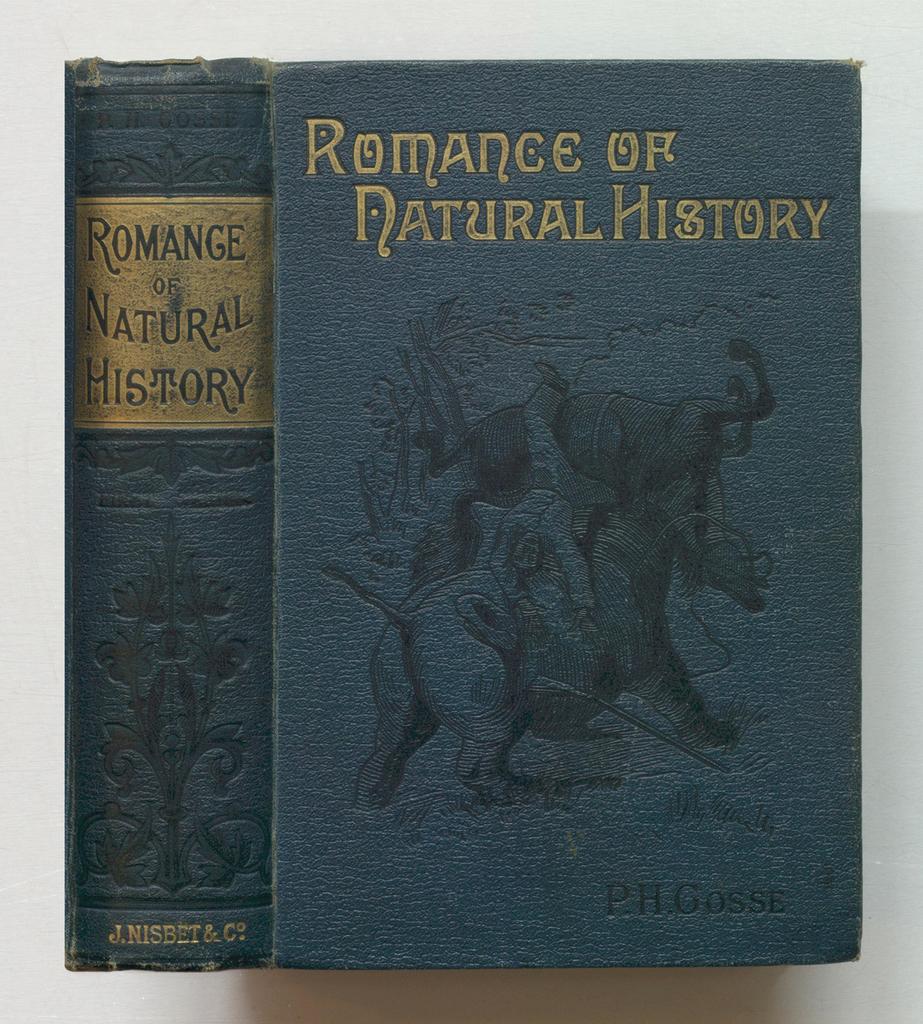Who wrote the romance of natural history?
Provide a short and direct response. P.h. gosse. Who is the publisher?
Your answer should be compact. J. nisbet & co. 